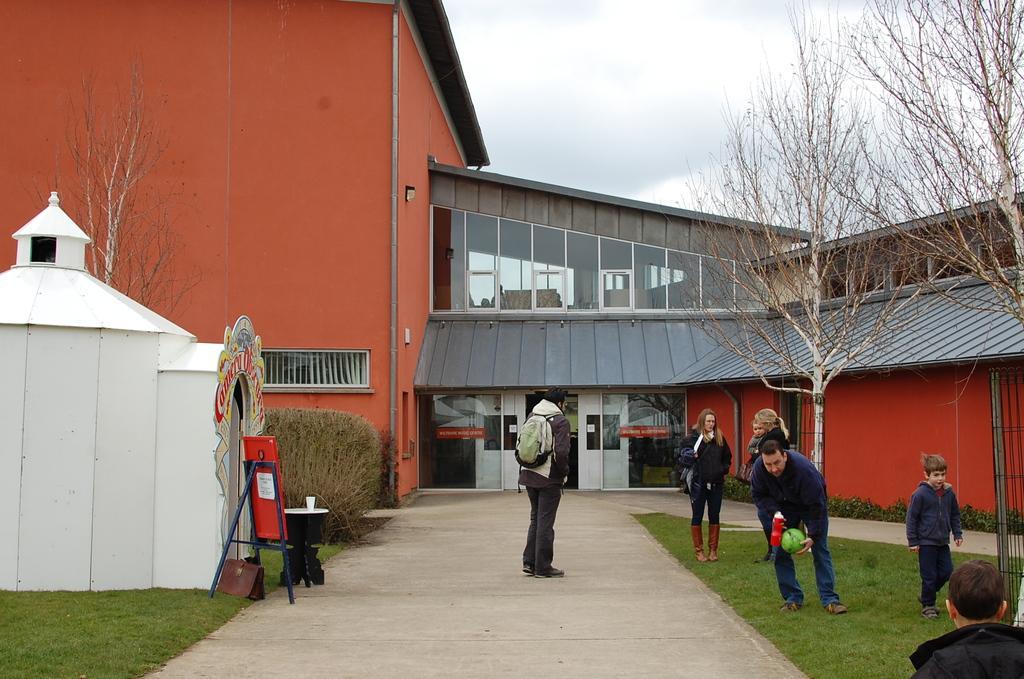Could you give a brief overview of what you see in this image? In the picture I can see these people are walking on the grass and this person wearing a backpack is standing on the way. Here we can see a boat, table, two objects and a white color house. In the background, we can see the shrubs, dry trees, house and the sky with clouds. 